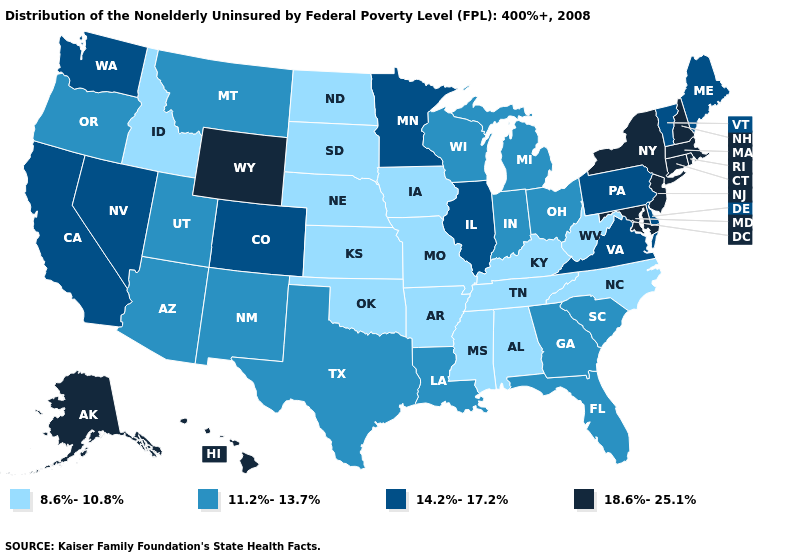What is the value of Alaska?
Be succinct. 18.6%-25.1%. Which states have the lowest value in the USA?
Concise answer only. Alabama, Arkansas, Idaho, Iowa, Kansas, Kentucky, Mississippi, Missouri, Nebraska, North Carolina, North Dakota, Oklahoma, South Dakota, Tennessee, West Virginia. Name the states that have a value in the range 18.6%-25.1%?
Write a very short answer. Alaska, Connecticut, Hawaii, Maryland, Massachusetts, New Hampshire, New Jersey, New York, Rhode Island, Wyoming. Is the legend a continuous bar?
Short answer required. No. What is the value of Illinois?
Keep it brief. 14.2%-17.2%. What is the value of New Hampshire?
Concise answer only. 18.6%-25.1%. Which states have the highest value in the USA?
Write a very short answer. Alaska, Connecticut, Hawaii, Maryland, Massachusetts, New Hampshire, New Jersey, New York, Rhode Island, Wyoming. Which states have the lowest value in the Northeast?
Concise answer only. Maine, Pennsylvania, Vermont. What is the value of Georgia?
Concise answer only. 11.2%-13.7%. What is the value of New Hampshire?
Give a very brief answer. 18.6%-25.1%. Does South Dakota have the same value as Kansas?
Write a very short answer. Yes. Which states have the lowest value in the South?
Keep it brief. Alabama, Arkansas, Kentucky, Mississippi, North Carolina, Oklahoma, Tennessee, West Virginia. What is the value of Montana?
Concise answer only. 11.2%-13.7%. Among the states that border Kansas , does Colorado have the lowest value?
Keep it brief. No. Does South Dakota have the lowest value in the USA?
Keep it brief. Yes. 